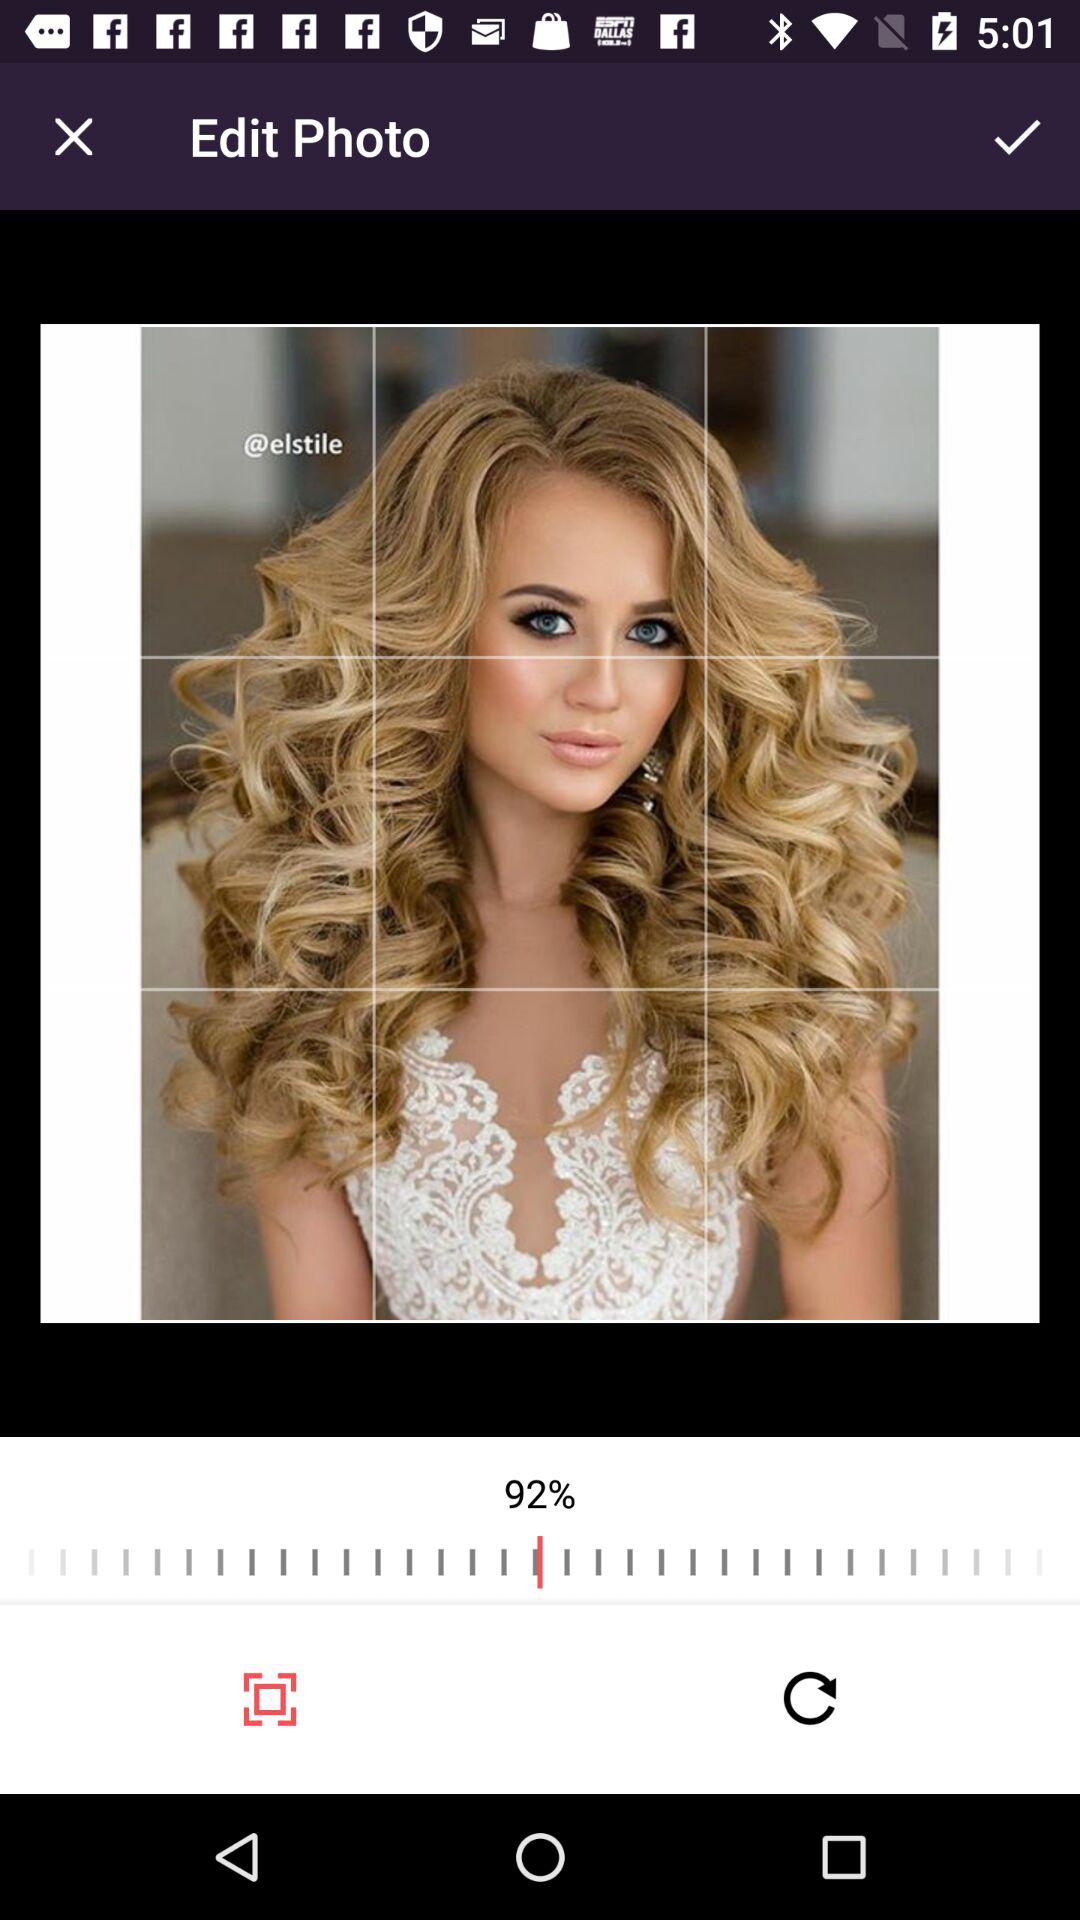What is the name of the photo?
When the provided information is insufficient, respond with <no answer>. <no answer> 